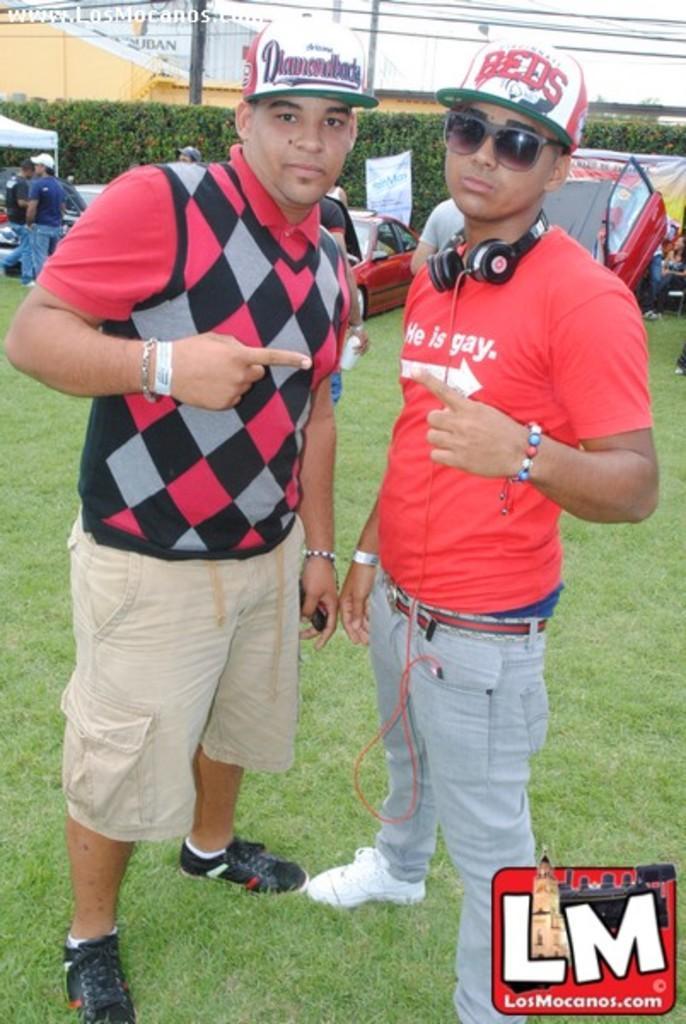How would you summarize this image in a sentence or two? This picture is clicked outside. In the foreground there are two men wearing red color t-shirts and hats and standing on the ground. In the background we can see the green grass, group of person standing on the ground and there are some vehicles and some other objects and we can see the buildings, cables, poles and plants. At the bottom right corner there is a watermark on the image. 